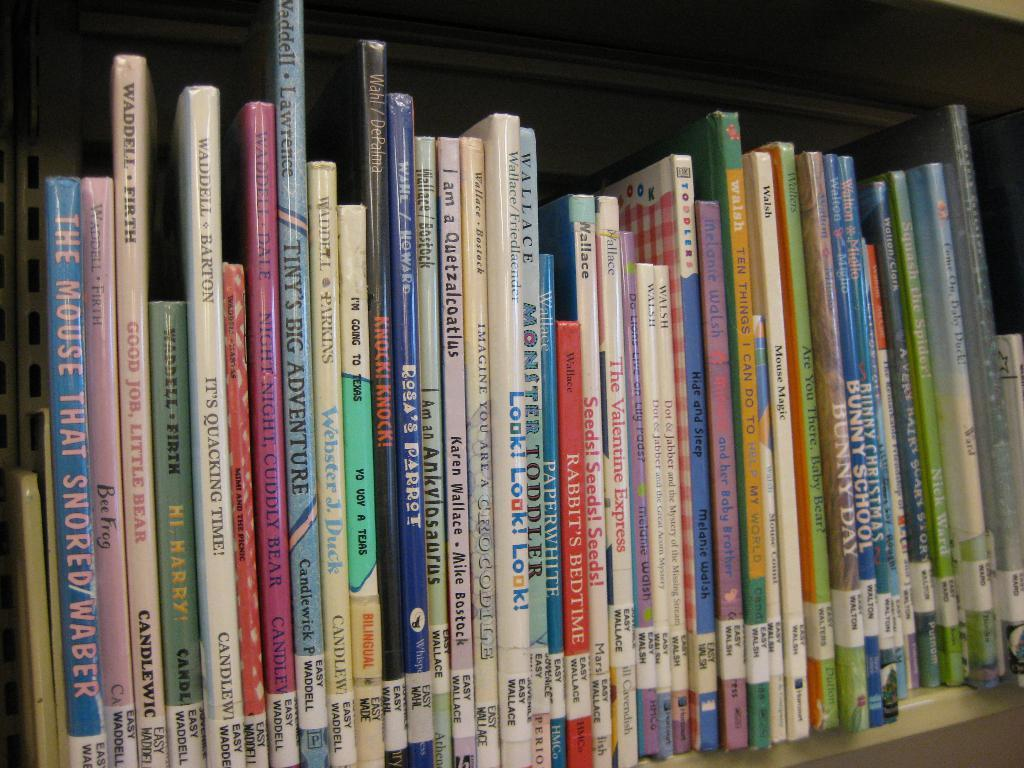Provide a one-sentence caption for the provided image. the word mouse is on the blue book. 